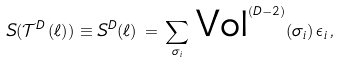<formula> <loc_0><loc_0><loc_500><loc_500>S ( \mathcal { T } ^ { D } \, ( \ell ) ) \equiv S ^ { D } ( \ell ) \, = \, \sum _ { \sigma _ { i } } \, \text {Vol} ^ { ( D - 2 ) } ( \sigma _ { i } ) \, \epsilon _ { i } \, ,</formula> 